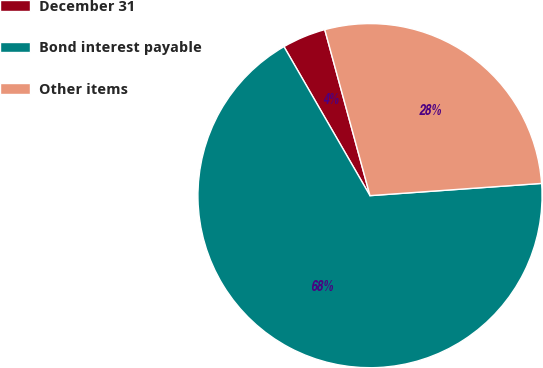<chart> <loc_0><loc_0><loc_500><loc_500><pie_chart><fcel>December 31<fcel>Bond interest payable<fcel>Other items<nl><fcel>4.1%<fcel>67.8%<fcel>28.1%<nl></chart> 